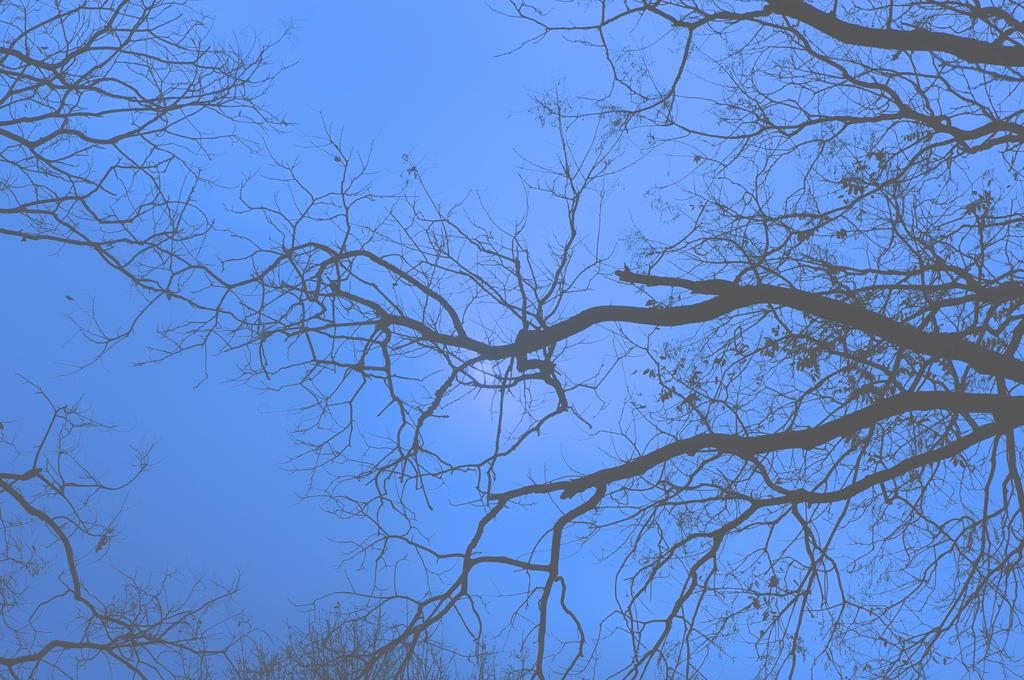What type of natural elements can be seen in the image? There are branches in the image. What is visible in the background of the image? There is a sky visible in the background of the image. What is the purpose of the riddle in the image? There is no riddle present in the image, so it cannot have a purpose within the context of the image. 